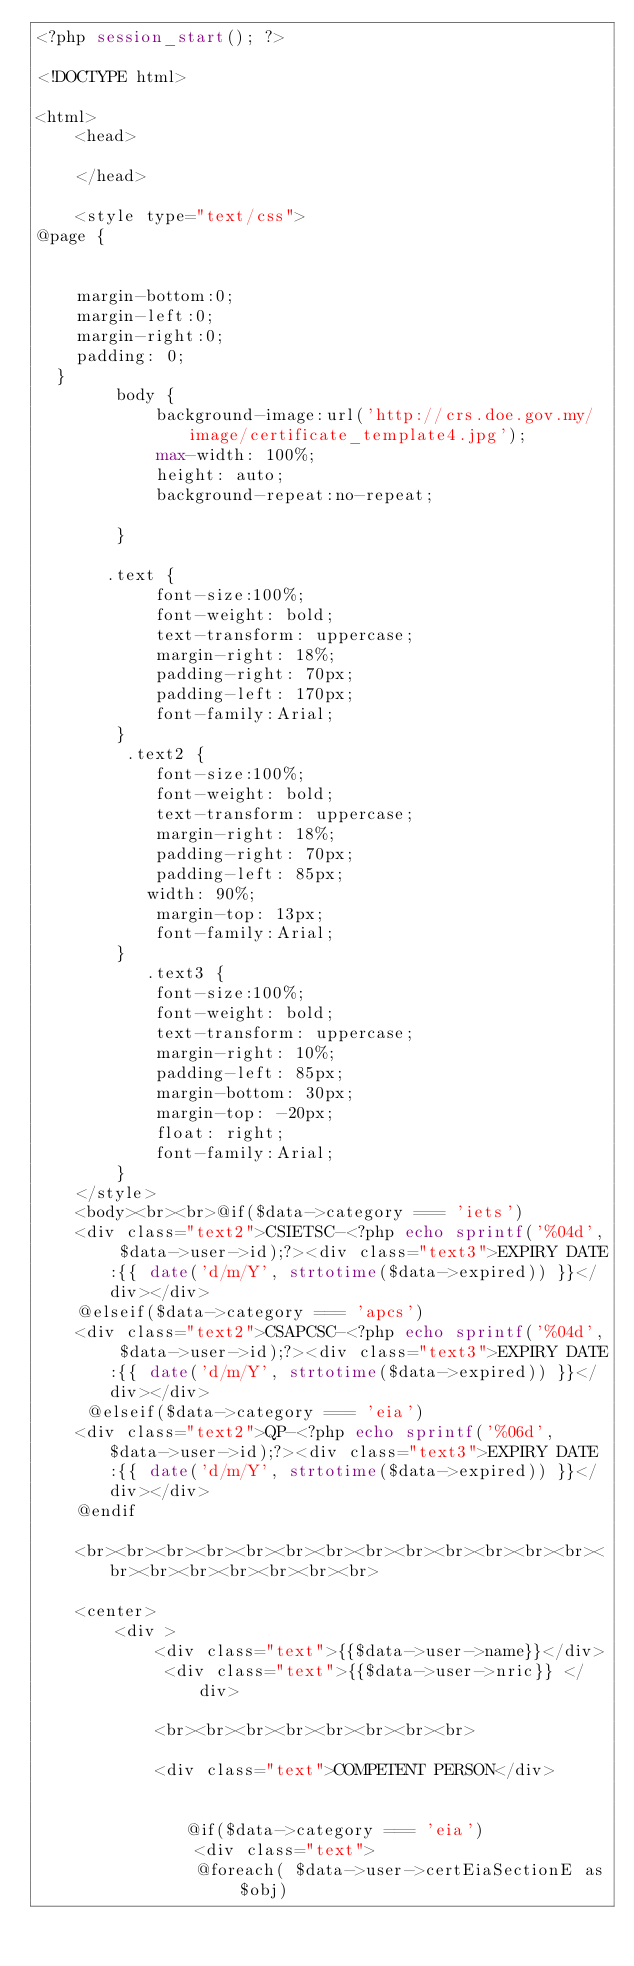Convert code to text. <code><loc_0><loc_0><loc_500><loc_500><_PHP_><?php session_start(); ?>

<!DOCTYPE html>

<html>
    <head>

    </head>

    <style type="text/css">
@page {
    
  
    margin-bottom:0;
    margin-left:0;
    margin-right:0;
    padding: 0;
  }
        body {
            background-image:url('http://crs.doe.gov.my/image/certificate_template4.jpg');
            max-width: 100%;
            height: auto;
            background-repeat:no-repeat;
           
        }
        
       .text {
            font-size:100%;
            font-weight: bold;
            text-transform: uppercase;
            margin-right: 18%;
            padding-right: 70px;
            padding-left: 170px;
            font-family:Arial;
        }
         .text2 {
            font-size:100%;
            font-weight: bold;
            text-transform: uppercase;
            margin-right: 18%;
            padding-right: 70px;
            padding-left: 85px;
           width: 90%;
            margin-top: 13px;
            font-family:Arial;
        }
           .text3 {
            font-size:100%;
            font-weight: bold;
            text-transform: uppercase;
            margin-right: 10%;
            padding-left: 85px;
            margin-bottom: 30px;
            margin-top: -20px;
            float: right;
            font-family:Arial;
        }
    </style>
    <body><br><br>@if($data->category === 'iets')
    <div class="text2">CSIETSC-<?php echo sprintf('%04d', $data->user->id);?><div class="text3">EXPIRY DATE:{{ date('d/m/Y', strtotime($data->expired)) }}</div></div>
    @elseif($data->category === 'apcs')
    <div class="text2">CSAPCSC-<?php echo sprintf('%04d', $data->user->id);?><div class="text3">EXPIRY DATE:{{ date('d/m/Y', strtotime($data->expired)) }}</div></div>
     @elseif($data->category === 'eia')
    <div class="text2">QP-<?php echo sprintf('%06d', $data->user->id);?><div class="text3">EXPIRY DATE:{{ date('d/m/Y', strtotime($data->expired)) }}</div></div>
    @endif
     
    <br><br><br><br><br><br><br><br><br><br><br><br><br><br><br><br><br><br><br><br>
   
    <center>
        <div >
            <div class="text">{{$data->user->name}}</div>
             <div class="text">{{$data->user->nric}} </div>
            
            <br><br><br><br><br><br><br><br>
          
            <div class="text">COMPETENT PERSON</div>
          
                
               @if($data->category === 'eia')
                <div class="text">
                @foreach( $data->user->certEiaSectionE as $obj)</code> 